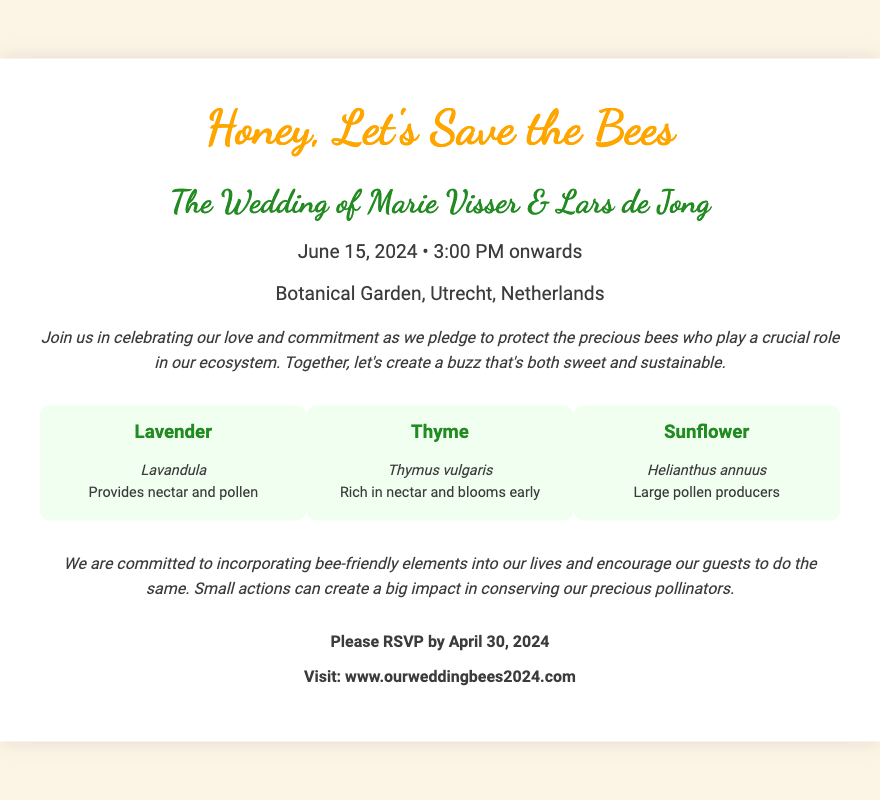What is the event date? The event date is specified in the document as June 15, 2024.
Answer: June 15, 2024 Who are the couple getting married? The document mentions the couple as Marie Visser & Lars de Jong.
Answer: Marie Visser & Lars de Jong Where is the wedding venue? The venue is described in the document as the Botanical Garden, Utrecht.
Answer: Botanical Garden, Utrecht What flower is known for providing nectar and pollen? Lavender is noted in the document for providing nectar and pollen.
Answer: Lavender What is the RSVP deadline? The RSVP deadline is indicated as April 30, 2024 in the document.
Answer: April 30, 2024 What is the primary theme of the wedding? The document emphasizes bee conservation as the primary theme.
Answer: Bee conservation Which flower blooms early and is rich in nectar? The document highlights Thyme as a flower that blooms early and is rich in nectar.
Answer: Thyme What is the website for RSVPs? The RSVP website mentioned in the document is www.ourweddingbees2024.com.
Answer: www.ourweddingbees2024.com What color is used for the wedding title? The title color specified in the document is orange.
Answer: Orange 